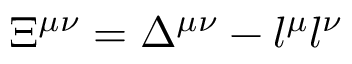Convert formula to latex. <formula><loc_0><loc_0><loc_500><loc_500>\Xi ^ { \mu \nu } = \Delta ^ { \mu \nu } - l ^ { \mu } l ^ { \nu }</formula> 